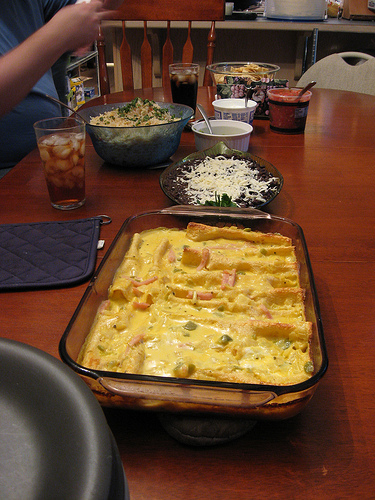<image>
Is the drink to the left of the casserole? Yes. From this viewpoint, the drink is positioned to the left side relative to the casserole. 